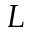Convert formula to latex. <formula><loc_0><loc_0><loc_500><loc_500>L</formula> 